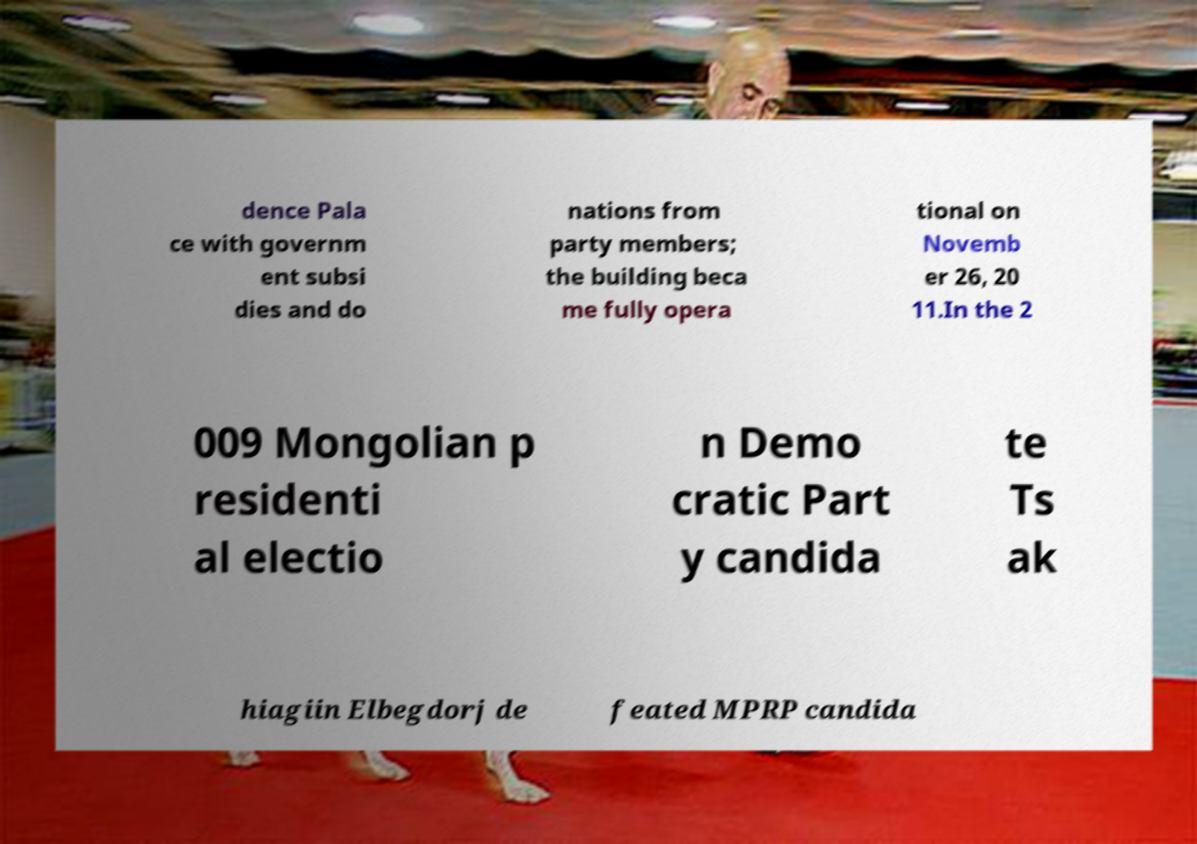There's text embedded in this image that I need extracted. Can you transcribe it verbatim? dence Pala ce with governm ent subsi dies and do nations from party members; the building beca me fully opera tional on Novemb er 26, 20 11.In the 2 009 Mongolian p residenti al electio n Demo cratic Part y candida te Ts ak hiagiin Elbegdorj de feated MPRP candida 